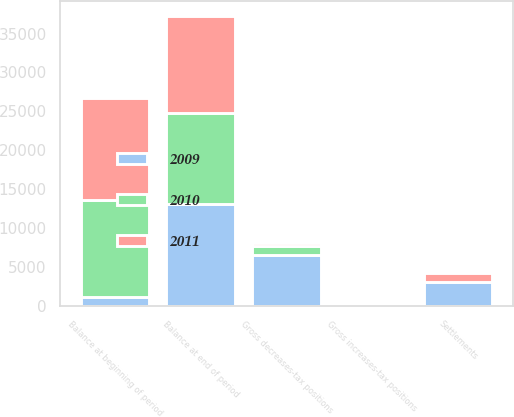Convert chart. <chart><loc_0><loc_0><loc_500><loc_500><stacked_bar_chart><ecel><fcel>Balance at beginning of period<fcel>Gross increases-tax positions<fcel>Gross decreases-tax positions<fcel>Settlements<fcel>Balance at end of period<nl><fcel>2010<fcel>12505<fcel>40<fcel>1061<fcel>111<fcel>11669<nl><fcel>2011<fcel>13135<fcel>64<fcel>493<fcel>1111<fcel>12505<nl><fcel>2009<fcel>1111<fcel>130<fcel>6592<fcel>3040<fcel>13135<nl></chart> 